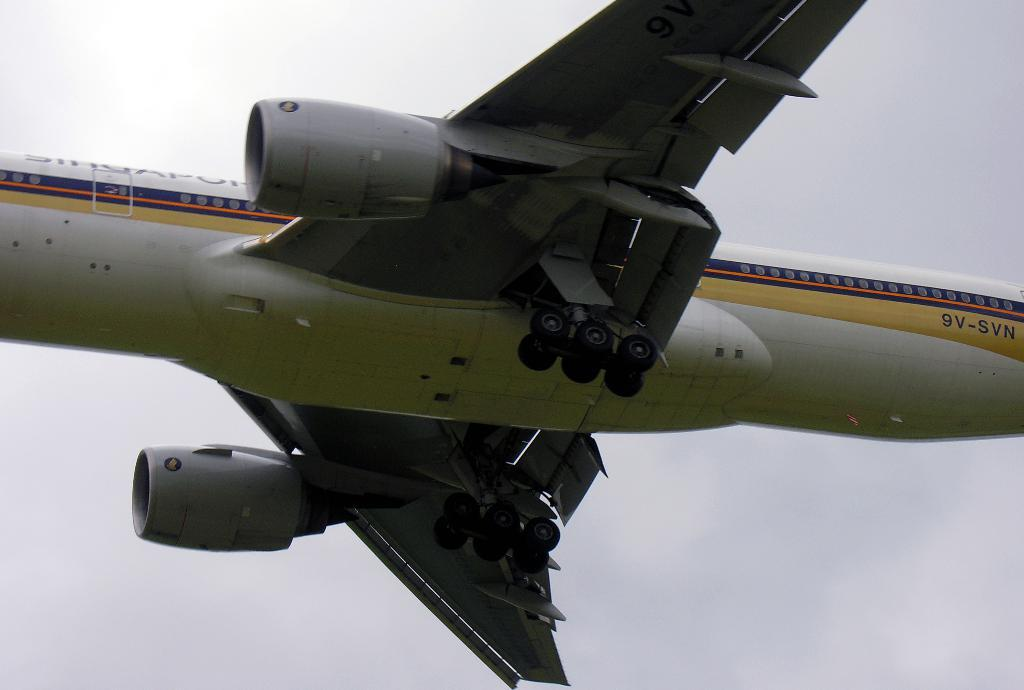What is the main subject of the image? The main subject of the image is an airplane. What is the airplane doing in the image? The airplane is flying in the air. What can be seen in the background of the image? There is sky visible in the background of the image. How many frogs are sitting on the wings of the airplane in the image? There are no frogs present in the image, so it is not possible to determine how many might be sitting on the wings. 